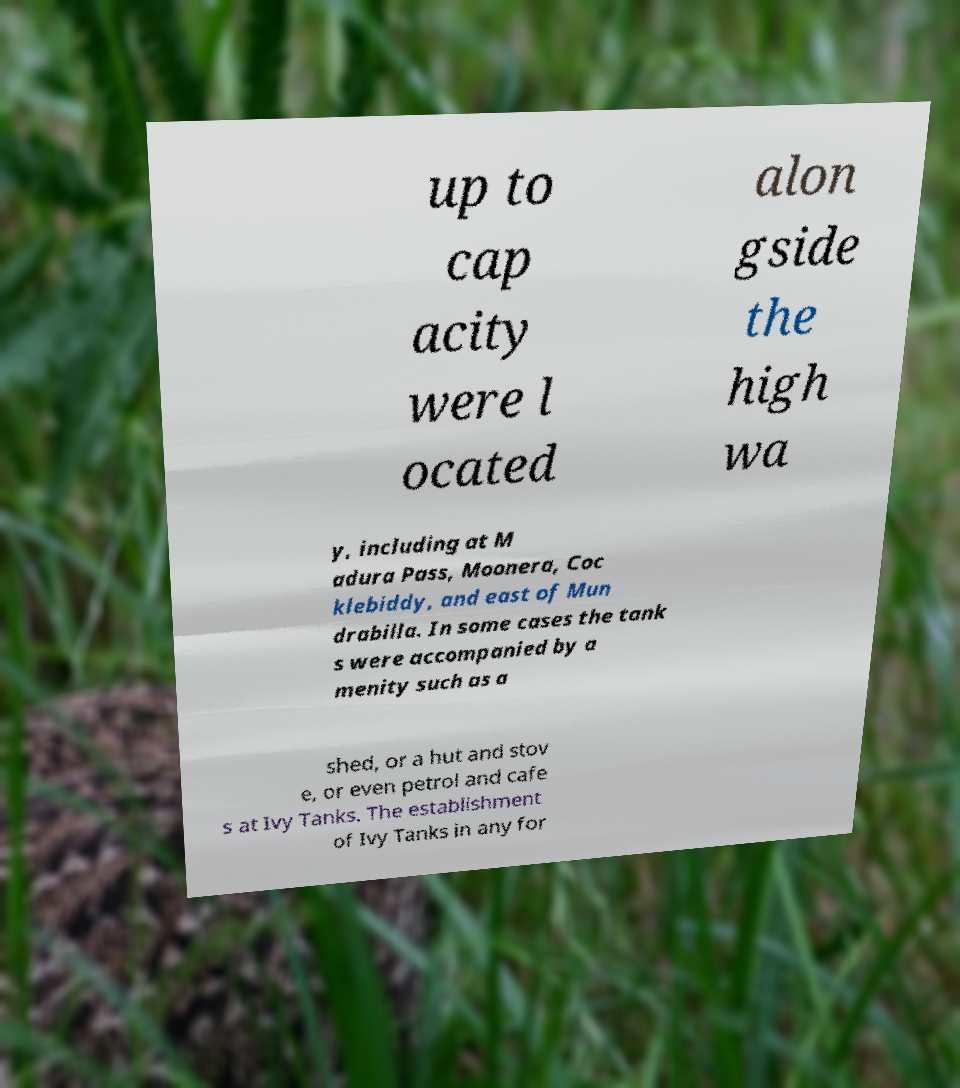Please identify and transcribe the text found in this image. up to cap acity were l ocated alon gside the high wa y, including at M adura Pass, Moonera, Coc klebiddy, and east of Mun drabilla. In some cases the tank s were accompanied by a menity such as a shed, or a hut and stov e, or even petrol and cafe s at Ivy Tanks. The establishment of Ivy Tanks in any for 